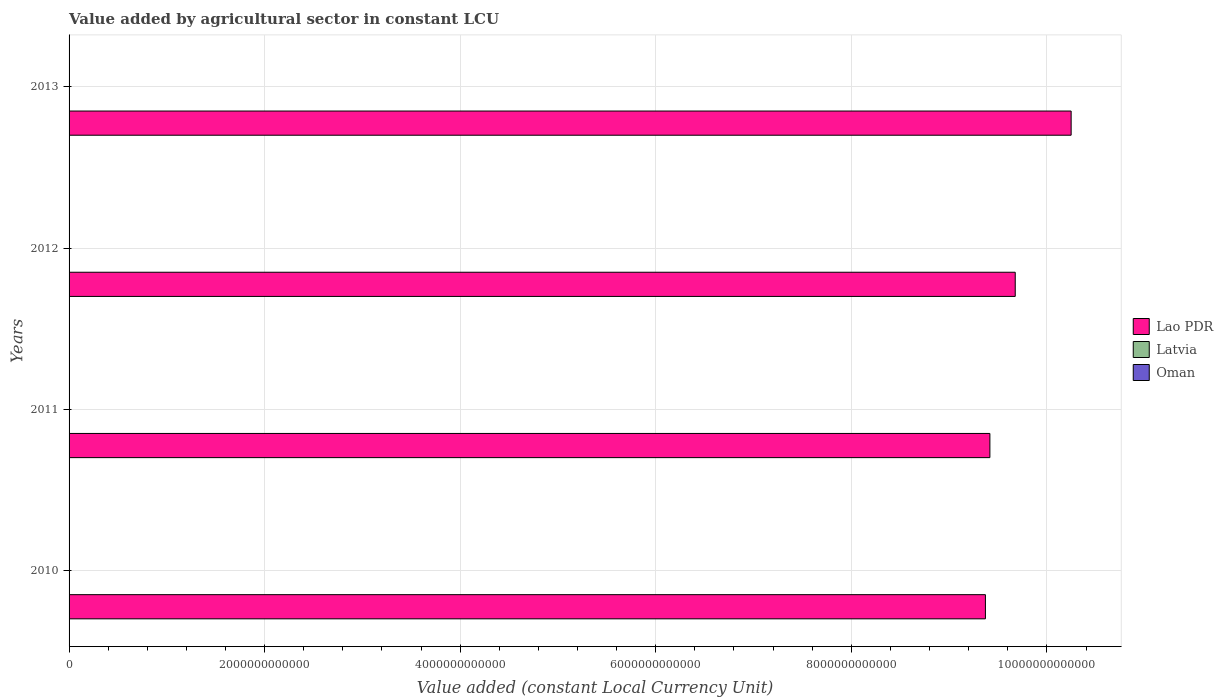How many groups of bars are there?
Give a very brief answer. 4. Are the number of bars per tick equal to the number of legend labels?
Your response must be concise. Yes. What is the value added by agricultural sector in Latvia in 2012?
Your answer should be very brief. 7.46e+08. Across all years, what is the maximum value added by agricultural sector in Oman?
Make the answer very short. 3.34e+08. Across all years, what is the minimum value added by agricultural sector in Oman?
Give a very brief answer. 3.10e+08. In which year was the value added by agricultural sector in Lao PDR minimum?
Offer a very short reply. 2010. What is the total value added by agricultural sector in Latvia in the graph?
Ensure brevity in your answer.  2.90e+09. What is the difference between the value added by agricultural sector in Lao PDR in 2011 and that in 2012?
Ensure brevity in your answer.  -2.59e+11. What is the difference between the value added by agricultural sector in Oman in 2011 and the value added by agricultural sector in Latvia in 2013?
Your answer should be very brief. -4.45e+08. What is the average value added by agricultural sector in Oman per year?
Your response must be concise. 3.19e+08. In the year 2013, what is the difference between the value added by agricultural sector in Lao PDR and value added by agricultural sector in Oman?
Give a very brief answer. 1.02e+13. In how many years, is the value added by agricultural sector in Lao PDR greater than 3200000000000 LCU?
Keep it short and to the point. 4. What is the ratio of the value added by agricultural sector in Latvia in 2010 to that in 2011?
Offer a very short reply. 1.02. Is the value added by agricultural sector in Latvia in 2010 less than that in 2012?
Ensure brevity in your answer.  Yes. What is the difference between the highest and the second highest value added by agricultural sector in Latvia?
Offer a terse response. 9.24e+06. What is the difference between the highest and the lowest value added by agricultural sector in Latvia?
Give a very brief answer. 6.06e+07. In how many years, is the value added by agricultural sector in Oman greater than the average value added by agricultural sector in Oman taken over all years?
Ensure brevity in your answer.  1. Is the sum of the value added by agricultural sector in Oman in 2011 and 2013 greater than the maximum value added by agricultural sector in Latvia across all years?
Ensure brevity in your answer.  No. What does the 1st bar from the top in 2010 represents?
Ensure brevity in your answer.  Oman. What does the 2nd bar from the bottom in 2011 represents?
Provide a succinct answer. Latvia. Is it the case that in every year, the sum of the value added by agricultural sector in Latvia and value added by agricultural sector in Oman is greater than the value added by agricultural sector in Lao PDR?
Make the answer very short. No. Are all the bars in the graph horizontal?
Your answer should be very brief. Yes. What is the difference between two consecutive major ticks on the X-axis?
Provide a succinct answer. 2.00e+12. Does the graph contain any zero values?
Provide a short and direct response. No. Does the graph contain grids?
Ensure brevity in your answer.  Yes. What is the title of the graph?
Give a very brief answer. Value added by agricultural sector in constant LCU. Does "Brunei Darussalam" appear as one of the legend labels in the graph?
Your answer should be very brief. No. What is the label or title of the X-axis?
Provide a short and direct response. Value added (constant Local Currency Unit). What is the label or title of the Y-axis?
Provide a succinct answer. Years. What is the Value added (constant Local Currency Unit) of Lao PDR in 2010?
Your answer should be compact. 9.37e+12. What is the Value added (constant Local Currency Unit) of Latvia in 2010?
Offer a terse response. 7.06e+08. What is the Value added (constant Local Currency Unit) of Oman in 2010?
Your response must be concise. 3.12e+08. What is the Value added (constant Local Currency Unit) in Lao PDR in 2011?
Give a very brief answer. 9.42e+12. What is the Value added (constant Local Currency Unit) in Latvia in 2011?
Offer a very short reply. 6.94e+08. What is the Value added (constant Local Currency Unit) of Oman in 2011?
Your answer should be compact. 3.10e+08. What is the Value added (constant Local Currency Unit) of Lao PDR in 2012?
Keep it short and to the point. 9.68e+12. What is the Value added (constant Local Currency Unit) in Latvia in 2012?
Your answer should be very brief. 7.46e+08. What is the Value added (constant Local Currency Unit) of Oman in 2012?
Your answer should be compact. 3.18e+08. What is the Value added (constant Local Currency Unit) of Lao PDR in 2013?
Provide a succinct answer. 1.02e+13. What is the Value added (constant Local Currency Unit) of Latvia in 2013?
Your response must be concise. 7.55e+08. What is the Value added (constant Local Currency Unit) in Oman in 2013?
Make the answer very short. 3.34e+08. Across all years, what is the maximum Value added (constant Local Currency Unit) of Lao PDR?
Ensure brevity in your answer.  1.02e+13. Across all years, what is the maximum Value added (constant Local Currency Unit) of Latvia?
Ensure brevity in your answer.  7.55e+08. Across all years, what is the maximum Value added (constant Local Currency Unit) of Oman?
Offer a terse response. 3.34e+08. Across all years, what is the minimum Value added (constant Local Currency Unit) in Lao PDR?
Provide a short and direct response. 9.37e+12. Across all years, what is the minimum Value added (constant Local Currency Unit) in Latvia?
Keep it short and to the point. 6.94e+08. Across all years, what is the minimum Value added (constant Local Currency Unit) in Oman?
Keep it short and to the point. 3.10e+08. What is the total Value added (constant Local Currency Unit) of Lao PDR in the graph?
Your response must be concise. 3.87e+13. What is the total Value added (constant Local Currency Unit) in Latvia in the graph?
Your answer should be compact. 2.90e+09. What is the total Value added (constant Local Currency Unit) in Oman in the graph?
Your answer should be compact. 1.27e+09. What is the difference between the Value added (constant Local Currency Unit) in Lao PDR in 2010 and that in 2011?
Provide a succinct answer. -4.57e+1. What is the difference between the Value added (constant Local Currency Unit) in Latvia in 2010 and that in 2011?
Offer a very short reply. 1.22e+07. What is the difference between the Value added (constant Local Currency Unit) of Oman in 2010 and that in 2011?
Make the answer very short. 1.60e+06. What is the difference between the Value added (constant Local Currency Unit) in Lao PDR in 2010 and that in 2012?
Offer a terse response. -3.05e+11. What is the difference between the Value added (constant Local Currency Unit) of Latvia in 2010 and that in 2012?
Your answer should be compact. -3.92e+07. What is the difference between the Value added (constant Local Currency Unit) in Oman in 2010 and that in 2012?
Your response must be concise. -6.50e+06. What is the difference between the Value added (constant Local Currency Unit) in Lao PDR in 2010 and that in 2013?
Offer a terse response. -8.77e+11. What is the difference between the Value added (constant Local Currency Unit) in Latvia in 2010 and that in 2013?
Offer a terse response. -4.84e+07. What is the difference between the Value added (constant Local Currency Unit) of Oman in 2010 and that in 2013?
Offer a terse response. -2.27e+07. What is the difference between the Value added (constant Local Currency Unit) in Lao PDR in 2011 and that in 2012?
Keep it short and to the point. -2.59e+11. What is the difference between the Value added (constant Local Currency Unit) of Latvia in 2011 and that in 2012?
Ensure brevity in your answer.  -5.14e+07. What is the difference between the Value added (constant Local Currency Unit) of Oman in 2011 and that in 2012?
Keep it short and to the point. -8.10e+06. What is the difference between the Value added (constant Local Currency Unit) in Lao PDR in 2011 and that in 2013?
Your answer should be very brief. -8.31e+11. What is the difference between the Value added (constant Local Currency Unit) in Latvia in 2011 and that in 2013?
Provide a short and direct response. -6.06e+07. What is the difference between the Value added (constant Local Currency Unit) in Oman in 2011 and that in 2013?
Your answer should be compact. -2.43e+07. What is the difference between the Value added (constant Local Currency Unit) of Lao PDR in 2012 and that in 2013?
Your answer should be compact. -5.72e+11. What is the difference between the Value added (constant Local Currency Unit) in Latvia in 2012 and that in 2013?
Provide a succinct answer. -9.24e+06. What is the difference between the Value added (constant Local Currency Unit) in Oman in 2012 and that in 2013?
Give a very brief answer. -1.62e+07. What is the difference between the Value added (constant Local Currency Unit) in Lao PDR in 2010 and the Value added (constant Local Currency Unit) in Latvia in 2011?
Provide a short and direct response. 9.37e+12. What is the difference between the Value added (constant Local Currency Unit) of Lao PDR in 2010 and the Value added (constant Local Currency Unit) of Oman in 2011?
Provide a succinct answer. 9.37e+12. What is the difference between the Value added (constant Local Currency Unit) in Latvia in 2010 and the Value added (constant Local Currency Unit) in Oman in 2011?
Offer a very short reply. 3.96e+08. What is the difference between the Value added (constant Local Currency Unit) of Lao PDR in 2010 and the Value added (constant Local Currency Unit) of Latvia in 2012?
Your answer should be very brief. 9.37e+12. What is the difference between the Value added (constant Local Currency Unit) of Lao PDR in 2010 and the Value added (constant Local Currency Unit) of Oman in 2012?
Give a very brief answer. 9.37e+12. What is the difference between the Value added (constant Local Currency Unit) of Latvia in 2010 and the Value added (constant Local Currency Unit) of Oman in 2012?
Your answer should be very brief. 3.88e+08. What is the difference between the Value added (constant Local Currency Unit) of Lao PDR in 2010 and the Value added (constant Local Currency Unit) of Latvia in 2013?
Offer a very short reply. 9.37e+12. What is the difference between the Value added (constant Local Currency Unit) of Lao PDR in 2010 and the Value added (constant Local Currency Unit) of Oman in 2013?
Your answer should be compact. 9.37e+12. What is the difference between the Value added (constant Local Currency Unit) of Latvia in 2010 and the Value added (constant Local Currency Unit) of Oman in 2013?
Your answer should be very brief. 3.72e+08. What is the difference between the Value added (constant Local Currency Unit) in Lao PDR in 2011 and the Value added (constant Local Currency Unit) in Latvia in 2012?
Make the answer very short. 9.42e+12. What is the difference between the Value added (constant Local Currency Unit) of Lao PDR in 2011 and the Value added (constant Local Currency Unit) of Oman in 2012?
Give a very brief answer. 9.42e+12. What is the difference between the Value added (constant Local Currency Unit) in Latvia in 2011 and the Value added (constant Local Currency Unit) in Oman in 2012?
Your response must be concise. 3.76e+08. What is the difference between the Value added (constant Local Currency Unit) in Lao PDR in 2011 and the Value added (constant Local Currency Unit) in Latvia in 2013?
Offer a very short reply. 9.42e+12. What is the difference between the Value added (constant Local Currency Unit) of Lao PDR in 2011 and the Value added (constant Local Currency Unit) of Oman in 2013?
Your answer should be very brief. 9.42e+12. What is the difference between the Value added (constant Local Currency Unit) of Latvia in 2011 and the Value added (constant Local Currency Unit) of Oman in 2013?
Offer a very short reply. 3.60e+08. What is the difference between the Value added (constant Local Currency Unit) of Lao PDR in 2012 and the Value added (constant Local Currency Unit) of Latvia in 2013?
Provide a short and direct response. 9.68e+12. What is the difference between the Value added (constant Local Currency Unit) of Lao PDR in 2012 and the Value added (constant Local Currency Unit) of Oman in 2013?
Keep it short and to the point. 9.68e+12. What is the difference between the Value added (constant Local Currency Unit) of Latvia in 2012 and the Value added (constant Local Currency Unit) of Oman in 2013?
Your response must be concise. 4.11e+08. What is the average Value added (constant Local Currency Unit) of Lao PDR per year?
Your answer should be compact. 9.68e+12. What is the average Value added (constant Local Currency Unit) of Latvia per year?
Offer a terse response. 7.25e+08. What is the average Value added (constant Local Currency Unit) of Oman per year?
Your response must be concise. 3.19e+08. In the year 2010, what is the difference between the Value added (constant Local Currency Unit) in Lao PDR and Value added (constant Local Currency Unit) in Latvia?
Your response must be concise. 9.37e+12. In the year 2010, what is the difference between the Value added (constant Local Currency Unit) of Lao PDR and Value added (constant Local Currency Unit) of Oman?
Provide a short and direct response. 9.37e+12. In the year 2010, what is the difference between the Value added (constant Local Currency Unit) of Latvia and Value added (constant Local Currency Unit) of Oman?
Your answer should be compact. 3.95e+08. In the year 2011, what is the difference between the Value added (constant Local Currency Unit) of Lao PDR and Value added (constant Local Currency Unit) of Latvia?
Keep it short and to the point. 9.42e+12. In the year 2011, what is the difference between the Value added (constant Local Currency Unit) of Lao PDR and Value added (constant Local Currency Unit) of Oman?
Provide a succinct answer. 9.42e+12. In the year 2011, what is the difference between the Value added (constant Local Currency Unit) in Latvia and Value added (constant Local Currency Unit) in Oman?
Give a very brief answer. 3.84e+08. In the year 2012, what is the difference between the Value added (constant Local Currency Unit) in Lao PDR and Value added (constant Local Currency Unit) in Latvia?
Offer a terse response. 9.68e+12. In the year 2012, what is the difference between the Value added (constant Local Currency Unit) of Lao PDR and Value added (constant Local Currency Unit) of Oman?
Make the answer very short. 9.68e+12. In the year 2012, what is the difference between the Value added (constant Local Currency Unit) of Latvia and Value added (constant Local Currency Unit) of Oman?
Offer a terse response. 4.27e+08. In the year 2013, what is the difference between the Value added (constant Local Currency Unit) in Lao PDR and Value added (constant Local Currency Unit) in Latvia?
Give a very brief answer. 1.02e+13. In the year 2013, what is the difference between the Value added (constant Local Currency Unit) in Lao PDR and Value added (constant Local Currency Unit) in Oman?
Give a very brief answer. 1.02e+13. In the year 2013, what is the difference between the Value added (constant Local Currency Unit) of Latvia and Value added (constant Local Currency Unit) of Oman?
Keep it short and to the point. 4.20e+08. What is the ratio of the Value added (constant Local Currency Unit) in Lao PDR in 2010 to that in 2011?
Your response must be concise. 1. What is the ratio of the Value added (constant Local Currency Unit) in Latvia in 2010 to that in 2011?
Offer a very short reply. 1.02. What is the ratio of the Value added (constant Local Currency Unit) in Lao PDR in 2010 to that in 2012?
Provide a succinct answer. 0.97. What is the ratio of the Value added (constant Local Currency Unit) in Latvia in 2010 to that in 2012?
Your answer should be very brief. 0.95. What is the ratio of the Value added (constant Local Currency Unit) of Oman in 2010 to that in 2012?
Make the answer very short. 0.98. What is the ratio of the Value added (constant Local Currency Unit) of Lao PDR in 2010 to that in 2013?
Provide a succinct answer. 0.91. What is the ratio of the Value added (constant Local Currency Unit) of Latvia in 2010 to that in 2013?
Offer a very short reply. 0.94. What is the ratio of the Value added (constant Local Currency Unit) of Oman in 2010 to that in 2013?
Make the answer very short. 0.93. What is the ratio of the Value added (constant Local Currency Unit) of Lao PDR in 2011 to that in 2012?
Give a very brief answer. 0.97. What is the ratio of the Value added (constant Local Currency Unit) of Latvia in 2011 to that in 2012?
Your response must be concise. 0.93. What is the ratio of the Value added (constant Local Currency Unit) in Oman in 2011 to that in 2012?
Offer a very short reply. 0.97. What is the ratio of the Value added (constant Local Currency Unit) of Lao PDR in 2011 to that in 2013?
Give a very brief answer. 0.92. What is the ratio of the Value added (constant Local Currency Unit) of Latvia in 2011 to that in 2013?
Provide a succinct answer. 0.92. What is the ratio of the Value added (constant Local Currency Unit) in Oman in 2011 to that in 2013?
Make the answer very short. 0.93. What is the ratio of the Value added (constant Local Currency Unit) in Lao PDR in 2012 to that in 2013?
Give a very brief answer. 0.94. What is the ratio of the Value added (constant Local Currency Unit) of Latvia in 2012 to that in 2013?
Give a very brief answer. 0.99. What is the ratio of the Value added (constant Local Currency Unit) in Oman in 2012 to that in 2013?
Your response must be concise. 0.95. What is the difference between the highest and the second highest Value added (constant Local Currency Unit) of Lao PDR?
Keep it short and to the point. 5.72e+11. What is the difference between the highest and the second highest Value added (constant Local Currency Unit) in Latvia?
Your response must be concise. 9.24e+06. What is the difference between the highest and the second highest Value added (constant Local Currency Unit) in Oman?
Keep it short and to the point. 1.62e+07. What is the difference between the highest and the lowest Value added (constant Local Currency Unit) of Lao PDR?
Give a very brief answer. 8.77e+11. What is the difference between the highest and the lowest Value added (constant Local Currency Unit) of Latvia?
Make the answer very short. 6.06e+07. What is the difference between the highest and the lowest Value added (constant Local Currency Unit) in Oman?
Offer a very short reply. 2.43e+07. 